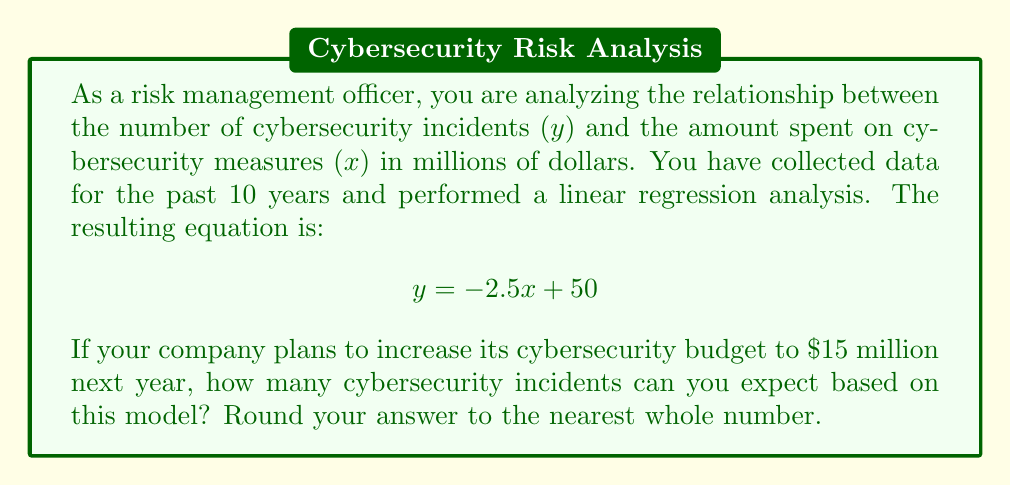What is the answer to this math problem? To solve this problem, we'll follow these steps:

1. Understand the given linear regression equation:
   $$ y = -2.5x + 50 $$
   Where:
   - $y$ is the number of cybersecurity incidents
   - $x$ is the amount spent on cybersecurity measures in millions of dollars

2. Identify the value of $x$ for next year's budget:
   $x = 15$ (million dollars)

3. Substitute $x = 15$ into the equation:
   $$ y = -2.5(15) + 50 $$

4. Solve the equation:
   $$ y = -37.5 + 50 $$
   $$ y = 12.5 $$

5. Round the result to the nearest whole number:
   12.5 rounds to 13

This linear regression model suggests a negative correlation between cybersecurity spending and the number of incidents. As spending increases, the number of incidents decreases. However, it's important to note that this is a simplified model and real-world scenarios may be more complex.
Answer: 13 cybersecurity incidents 